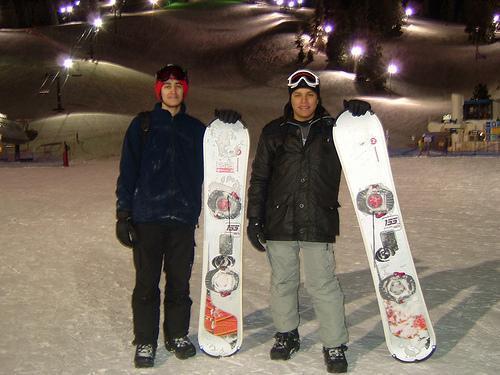How many people are in the picture?
Give a very brief answer. 2. How many snowboards are in the picture?
Give a very brief answer. 2. How many giraffe ossicones are there?
Give a very brief answer. 0. 